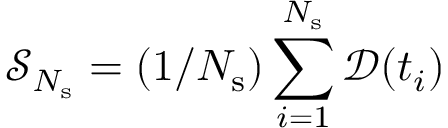Convert formula to latex. <formula><loc_0><loc_0><loc_500><loc_500>\mathcal { S } _ { N _ { s } } = ( 1 / N _ { s } ) \sum _ { i = 1 } ^ { N _ { s } } \mathcal { D } ( t _ { i } )</formula> 